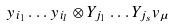Convert formula to latex. <formula><loc_0><loc_0><loc_500><loc_500>y _ { i _ { 1 } } \dots y _ { i _ { l } } \otimes Y _ { j _ { 1 } } \dots Y _ { j _ { s } } v _ { \mu }</formula> 